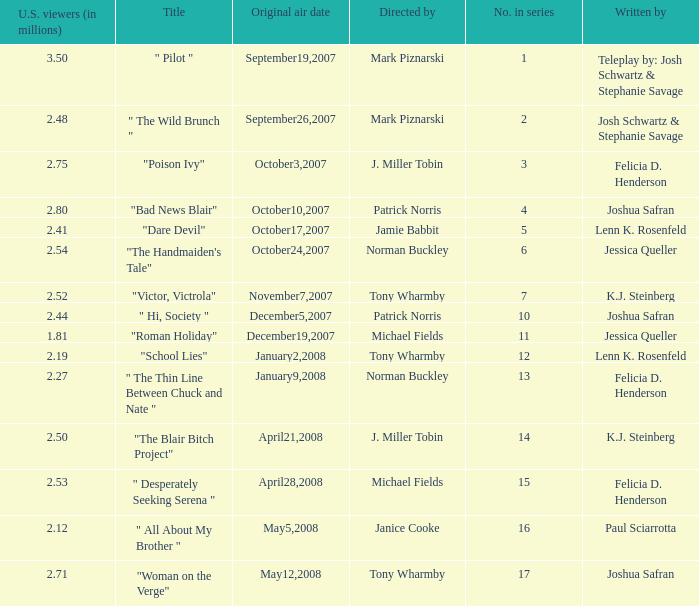What is the original air date when "poison ivy" is the title? October3,2007. 